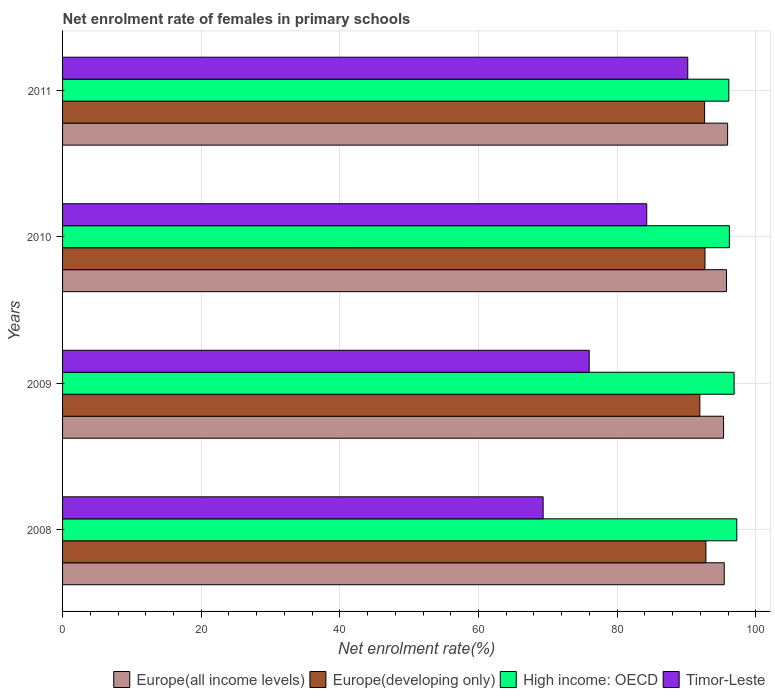How many different coloured bars are there?
Make the answer very short. 4. How many groups of bars are there?
Offer a very short reply. 4. Are the number of bars on each tick of the Y-axis equal?
Ensure brevity in your answer.  Yes. How many bars are there on the 3rd tick from the top?
Offer a very short reply. 4. What is the label of the 2nd group of bars from the top?
Make the answer very short. 2010. What is the net enrolment rate of females in primary schools in Europe(all income levels) in 2009?
Provide a succinct answer. 95.35. Across all years, what is the maximum net enrolment rate of females in primary schools in Europe(developing only)?
Provide a short and direct response. 92.81. Across all years, what is the minimum net enrolment rate of females in primary schools in Timor-Leste?
Provide a short and direct response. 69.33. In which year was the net enrolment rate of females in primary schools in Timor-Leste minimum?
Offer a terse response. 2008. What is the total net enrolment rate of females in primary schools in Europe(developing only) in the graph?
Offer a very short reply. 370.04. What is the difference between the net enrolment rate of females in primary schools in Timor-Leste in 2009 and that in 2011?
Offer a terse response. -14.22. What is the difference between the net enrolment rate of females in primary schools in Europe(developing only) in 2009 and the net enrolment rate of females in primary schools in Timor-Leste in 2011?
Your answer should be very brief. 1.74. What is the average net enrolment rate of females in primary schools in Timor-Leste per year?
Provide a succinct answer. 79.94. In the year 2011, what is the difference between the net enrolment rate of females in primary schools in Europe(all income levels) and net enrolment rate of females in primary schools in Europe(developing only)?
Provide a succinct answer. 3.32. In how many years, is the net enrolment rate of females in primary schools in Timor-Leste greater than 40 %?
Give a very brief answer. 4. What is the ratio of the net enrolment rate of females in primary schools in Timor-Leste in 2010 to that in 2011?
Keep it short and to the point. 0.93. What is the difference between the highest and the second highest net enrolment rate of females in primary schools in Timor-Leste?
Ensure brevity in your answer.  5.92. What is the difference between the highest and the lowest net enrolment rate of females in primary schools in Europe(all income levels)?
Provide a short and direct response. 0.59. In how many years, is the net enrolment rate of females in primary schools in High income: OECD greater than the average net enrolment rate of females in primary schools in High income: OECD taken over all years?
Offer a terse response. 2. Is it the case that in every year, the sum of the net enrolment rate of females in primary schools in Europe(all income levels) and net enrolment rate of females in primary schools in Timor-Leste is greater than the sum of net enrolment rate of females in primary schools in Europe(developing only) and net enrolment rate of females in primary schools in High income: OECD?
Ensure brevity in your answer.  No. What does the 3rd bar from the top in 2010 represents?
Offer a very short reply. Europe(developing only). What does the 4th bar from the bottom in 2008 represents?
Provide a succinct answer. Timor-Leste. How many bars are there?
Ensure brevity in your answer.  16. Are all the bars in the graph horizontal?
Ensure brevity in your answer.  Yes. What is the difference between two consecutive major ticks on the X-axis?
Keep it short and to the point. 20. Are the values on the major ticks of X-axis written in scientific E-notation?
Make the answer very short. No. Does the graph contain any zero values?
Ensure brevity in your answer.  No. Does the graph contain grids?
Give a very brief answer. Yes. Where does the legend appear in the graph?
Give a very brief answer. Bottom right. What is the title of the graph?
Your answer should be very brief. Net enrolment rate of females in primary schools. What is the label or title of the X-axis?
Make the answer very short. Net enrolment rate(%). What is the label or title of the Y-axis?
Keep it short and to the point. Years. What is the Net enrolment rate(%) in Europe(all income levels) in 2008?
Your answer should be very brief. 95.45. What is the Net enrolment rate(%) in Europe(developing only) in 2008?
Ensure brevity in your answer.  92.81. What is the Net enrolment rate(%) of High income: OECD in 2008?
Keep it short and to the point. 97.26. What is the Net enrolment rate(%) in Timor-Leste in 2008?
Your response must be concise. 69.33. What is the Net enrolment rate(%) of Europe(all income levels) in 2009?
Make the answer very short. 95.35. What is the Net enrolment rate(%) in Europe(developing only) in 2009?
Your answer should be very brief. 91.93. What is the Net enrolment rate(%) of High income: OECD in 2009?
Offer a terse response. 96.87. What is the Net enrolment rate(%) in Timor-Leste in 2009?
Keep it short and to the point. 75.97. What is the Net enrolment rate(%) in Europe(all income levels) in 2010?
Your response must be concise. 95.78. What is the Net enrolment rate(%) of Europe(developing only) in 2010?
Offer a terse response. 92.67. What is the Net enrolment rate(%) in High income: OECD in 2010?
Provide a succinct answer. 96.19. What is the Net enrolment rate(%) of Timor-Leste in 2010?
Offer a terse response. 84.27. What is the Net enrolment rate(%) in Europe(all income levels) in 2011?
Make the answer very short. 95.94. What is the Net enrolment rate(%) of Europe(developing only) in 2011?
Provide a succinct answer. 92.62. What is the Net enrolment rate(%) of High income: OECD in 2011?
Offer a very short reply. 96.12. What is the Net enrolment rate(%) of Timor-Leste in 2011?
Give a very brief answer. 90.19. Across all years, what is the maximum Net enrolment rate(%) in Europe(all income levels)?
Offer a terse response. 95.94. Across all years, what is the maximum Net enrolment rate(%) in Europe(developing only)?
Your response must be concise. 92.81. Across all years, what is the maximum Net enrolment rate(%) of High income: OECD?
Offer a very short reply. 97.26. Across all years, what is the maximum Net enrolment rate(%) in Timor-Leste?
Your answer should be compact. 90.19. Across all years, what is the minimum Net enrolment rate(%) in Europe(all income levels)?
Ensure brevity in your answer.  95.35. Across all years, what is the minimum Net enrolment rate(%) of Europe(developing only)?
Provide a succinct answer. 91.93. Across all years, what is the minimum Net enrolment rate(%) of High income: OECD?
Ensure brevity in your answer.  96.12. Across all years, what is the minimum Net enrolment rate(%) of Timor-Leste?
Your answer should be compact. 69.33. What is the total Net enrolment rate(%) of Europe(all income levels) in the graph?
Make the answer very short. 382.52. What is the total Net enrolment rate(%) in Europe(developing only) in the graph?
Your answer should be very brief. 370.04. What is the total Net enrolment rate(%) of High income: OECD in the graph?
Provide a short and direct response. 386.44. What is the total Net enrolment rate(%) of Timor-Leste in the graph?
Your answer should be very brief. 319.76. What is the difference between the Net enrolment rate(%) of Europe(all income levels) in 2008 and that in 2009?
Provide a succinct answer. 0.1. What is the difference between the Net enrolment rate(%) of Europe(developing only) in 2008 and that in 2009?
Offer a terse response. 0.88. What is the difference between the Net enrolment rate(%) in High income: OECD in 2008 and that in 2009?
Provide a short and direct response. 0.39. What is the difference between the Net enrolment rate(%) of Timor-Leste in 2008 and that in 2009?
Your response must be concise. -6.64. What is the difference between the Net enrolment rate(%) in Europe(all income levels) in 2008 and that in 2010?
Give a very brief answer. -0.32. What is the difference between the Net enrolment rate(%) of Europe(developing only) in 2008 and that in 2010?
Keep it short and to the point. 0.13. What is the difference between the Net enrolment rate(%) of High income: OECD in 2008 and that in 2010?
Offer a very short reply. 1.07. What is the difference between the Net enrolment rate(%) in Timor-Leste in 2008 and that in 2010?
Provide a short and direct response. -14.94. What is the difference between the Net enrolment rate(%) in Europe(all income levels) in 2008 and that in 2011?
Offer a very short reply. -0.49. What is the difference between the Net enrolment rate(%) of Europe(developing only) in 2008 and that in 2011?
Your response must be concise. 0.19. What is the difference between the Net enrolment rate(%) of High income: OECD in 2008 and that in 2011?
Offer a terse response. 1.15. What is the difference between the Net enrolment rate(%) of Timor-Leste in 2008 and that in 2011?
Your answer should be compact. -20.86. What is the difference between the Net enrolment rate(%) in Europe(all income levels) in 2009 and that in 2010?
Keep it short and to the point. -0.42. What is the difference between the Net enrolment rate(%) in Europe(developing only) in 2009 and that in 2010?
Give a very brief answer. -0.74. What is the difference between the Net enrolment rate(%) in High income: OECD in 2009 and that in 2010?
Ensure brevity in your answer.  0.68. What is the difference between the Net enrolment rate(%) in Timor-Leste in 2009 and that in 2010?
Provide a succinct answer. -8.3. What is the difference between the Net enrolment rate(%) of Europe(all income levels) in 2009 and that in 2011?
Make the answer very short. -0.59. What is the difference between the Net enrolment rate(%) of Europe(developing only) in 2009 and that in 2011?
Your answer should be very brief. -0.69. What is the difference between the Net enrolment rate(%) of High income: OECD in 2009 and that in 2011?
Provide a short and direct response. 0.76. What is the difference between the Net enrolment rate(%) of Timor-Leste in 2009 and that in 2011?
Offer a terse response. -14.22. What is the difference between the Net enrolment rate(%) in Europe(all income levels) in 2010 and that in 2011?
Give a very brief answer. -0.16. What is the difference between the Net enrolment rate(%) in Europe(developing only) in 2010 and that in 2011?
Your answer should be very brief. 0.05. What is the difference between the Net enrolment rate(%) in High income: OECD in 2010 and that in 2011?
Keep it short and to the point. 0.08. What is the difference between the Net enrolment rate(%) in Timor-Leste in 2010 and that in 2011?
Your response must be concise. -5.92. What is the difference between the Net enrolment rate(%) in Europe(all income levels) in 2008 and the Net enrolment rate(%) in Europe(developing only) in 2009?
Offer a very short reply. 3.52. What is the difference between the Net enrolment rate(%) in Europe(all income levels) in 2008 and the Net enrolment rate(%) in High income: OECD in 2009?
Offer a very short reply. -1.42. What is the difference between the Net enrolment rate(%) of Europe(all income levels) in 2008 and the Net enrolment rate(%) of Timor-Leste in 2009?
Offer a very short reply. 19.48. What is the difference between the Net enrolment rate(%) in Europe(developing only) in 2008 and the Net enrolment rate(%) in High income: OECD in 2009?
Offer a very short reply. -4.06. What is the difference between the Net enrolment rate(%) of Europe(developing only) in 2008 and the Net enrolment rate(%) of Timor-Leste in 2009?
Make the answer very short. 16.84. What is the difference between the Net enrolment rate(%) of High income: OECD in 2008 and the Net enrolment rate(%) of Timor-Leste in 2009?
Your answer should be compact. 21.29. What is the difference between the Net enrolment rate(%) of Europe(all income levels) in 2008 and the Net enrolment rate(%) of Europe(developing only) in 2010?
Ensure brevity in your answer.  2.78. What is the difference between the Net enrolment rate(%) of Europe(all income levels) in 2008 and the Net enrolment rate(%) of High income: OECD in 2010?
Make the answer very short. -0.74. What is the difference between the Net enrolment rate(%) of Europe(all income levels) in 2008 and the Net enrolment rate(%) of Timor-Leste in 2010?
Ensure brevity in your answer.  11.19. What is the difference between the Net enrolment rate(%) in Europe(developing only) in 2008 and the Net enrolment rate(%) in High income: OECD in 2010?
Your answer should be compact. -3.39. What is the difference between the Net enrolment rate(%) in Europe(developing only) in 2008 and the Net enrolment rate(%) in Timor-Leste in 2010?
Make the answer very short. 8.54. What is the difference between the Net enrolment rate(%) of High income: OECD in 2008 and the Net enrolment rate(%) of Timor-Leste in 2010?
Your answer should be compact. 12.99. What is the difference between the Net enrolment rate(%) in Europe(all income levels) in 2008 and the Net enrolment rate(%) in Europe(developing only) in 2011?
Provide a succinct answer. 2.83. What is the difference between the Net enrolment rate(%) of Europe(all income levels) in 2008 and the Net enrolment rate(%) of High income: OECD in 2011?
Your answer should be compact. -0.66. What is the difference between the Net enrolment rate(%) of Europe(all income levels) in 2008 and the Net enrolment rate(%) of Timor-Leste in 2011?
Your response must be concise. 5.26. What is the difference between the Net enrolment rate(%) of Europe(developing only) in 2008 and the Net enrolment rate(%) of High income: OECD in 2011?
Give a very brief answer. -3.31. What is the difference between the Net enrolment rate(%) of Europe(developing only) in 2008 and the Net enrolment rate(%) of Timor-Leste in 2011?
Keep it short and to the point. 2.62. What is the difference between the Net enrolment rate(%) of High income: OECD in 2008 and the Net enrolment rate(%) of Timor-Leste in 2011?
Provide a short and direct response. 7.07. What is the difference between the Net enrolment rate(%) in Europe(all income levels) in 2009 and the Net enrolment rate(%) in Europe(developing only) in 2010?
Your answer should be very brief. 2.68. What is the difference between the Net enrolment rate(%) in Europe(all income levels) in 2009 and the Net enrolment rate(%) in High income: OECD in 2010?
Give a very brief answer. -0.84. What is the difference between the Net enrolment rate(%) in Europe(all income levels) in 2009 and the Net enrolment rate(%) in Timor-Leste in 2010?
Your answer should be compact. 11.09. What is the difference between the Net enrolment rate(%) of Europe(developing only) in 2009 and the Net enrolment rate(%) of High income: OECD in 2010?
Provide a short and direct response. -4.26. What is the difference between the Net enrolment rate(%) of Europe(developing only) in 2009 and the Net enrolment rate(%) of Timor-Leste in 2010?
Ensure brevity in your answer.  7.66. What is the difference between the Net enrolment rate(%) of High income: OECD in 2009 and the Net enrolment rate(%) of Timor-Leste in 2010?
Make the answer very short. 12.6. What is the difference between the Net enrolment rate(%) of Europe(all income levels) in 2009 and the Net enrolment rate(%) of Europe(developing only) in 2011?
Offer a very short reply. 2.73. What is the difference between the Net enrolment rate(%) of Europe(all income levels) in 2009 and the Net enrolment rate(%) of High income: OECD in 2011?
Provide a succinct answer. -0.76. What is the difference between the Net enrolment rate(%) of Europe(all income levels) in 2009 and the Net enrolment rate(%) of Timor-Leste in 2011?
Provide a short and direct response. 5.16. What is the difference between the Net enrolment rate(%) in Europe(developing only) in 2009 and the Net enrolment rate(%) in High income: OECD in 2011?
Your answer should be very brief. -4.18. What is the difference between the Net enrolment rate(%) of Europe(developing only) in 2009 and the Net enrolment rate(%) of Timor-Leste in 2011?
Offer a terse response. 1.74. What is the difference between the Net enrolment rate(%) in High income: OECD in 2009 and the Net enrolment rate(%) in Timor-Leste in 2011?
Keep it short and to the point. 6.68. What is the difference between the Net enrolment rate(%) in Europe(all income levels) in 2010 and the Net enrolment rate(%) in Europe(developing only) in 2011?
Give a very brief answer. 3.15. What is the difference between the Net enrolment rate(%) of Europe(all income levels) in 2010 and the Net enrolment rate(%) of High income: OECD in 2011?
Your response must be concise. -0.34. What is the difference between the Net enrolment rate(%) of Europe(all income levels) in 2010 and the Net enrolment rate(%) of Timor-Leste in 2011?
Your answer should be very brief. 5.59. What is the difference between the Net enrolment rate(%) of Europe(developing only) in 2010 and the Net enrolment rate(%) of High income: OECD in 2011?
Ensure brevity in your answer.  -3.44. What is the difference between the Net enrolment rate(%) in Europe(developing only) in 2010 and the Net enrolment rate(%) in Timor-Leste in 2011?
Keep it short and to the point. 2.48. What is the difference between the Net enrolment rate(%) in High income: OECD in 2010 and the Net enrolment rate(%) in Timor-Leste in 2011?
Ensure brevity in your answer.  6.01. What is the average Net enrolment rate(%) in Europe(all income levels) per year?
Provide a short and direct response. 95.63. What is the average Net enrolment rate(%) in Europe(developing only) per year?
Your response must be concise. 92.51. What is the average Net enrolment rate(%) in High income: OECD per year?
Offer a very short reply. 96.61. What is the average Net enrolment rate(%) in Timor-Leste per year?
Your answer should be very brief. 79.94. In the year 2008, what is the difference between the Net enrolment rate(%) of Europe(all income levels) and Net enrolment rate(%) of Europe(developing only)?
Give a very brief answer. 2.65. In the year 2008, what is the difference between the Net enrolment rate(%) in Europe(all income levels) and Net enrolment rate(%) in High income: OECD?
Provide a short and direct response. -1.81. In the year 2008, what is the difference between the Net enrolment rate(%) of Europe(all income levels) and Net enrolment rate(%) of Timor-Leste?
Give a very brief answer. 26.13. In the year 2008, what is the difference between the Net enrolment rate(%) in Europe(developing only) and Net enrolment rate(%) in High income: OECD?
Ensure brevity in your answer.  -4.45. In the year 2008, what is the difference between the Net enrolment rate(%) of Europe(developing only) and Net enrolment rate(%) of Timor-Leste?
Your answer should be very brief. 23.48. In the year 2008, what is the difference between the Net enrolment rate(%) in High income: OECD and Net enrolment rate(%) in Timor-Leste?
Your response must be concise. 27.93. In the year 2009, what is the difference between the Net enrolment rate(%) of Europe(all income levels) and Net enrolment rate(%) of Europe(developing only)?
Provide a succinct answer. 3.42. In the year 2009, what is the difference between the Net enrolment rate(%) in Europe(all income levels) and Net enrolment rate(%) in High income: OECD?
Your answer should be compact. -1.52. In the year 2009, what is the difference between the Net enrolment rate(%) of Europe(all income levels) and Net enrolment rate(%) of Timor-Leste?
Provide a succinct answer. 19.38. In the year 2009, what is the difference between the Net enrolment rate(%) in Europe(developing only) and Net enrolment rate(%) in High income: OECD?
Give a very brief answer. -4.94. In the year 2009, what is the difference between the Net enrolment rate(%) in Europe(developing only) and Net enrolment rate(%) in Timor-Leste?
Your answer should be compact. 15.96. In the year 2009, what is the difference between the Net enrolment rate(%) in High income: OECD and Net enrolment rate(%) in Timor-Leste?
Ensure brevity in your answer.  20.9. In the year 2010, what is the difference between the Net enrolment rate(%) in Europe(all income levels) and Net enrolment rate(%) in Europe(developing only)?
Your answer should be compact. 3.1. In the year 2010, what is the difference between the Net enrolment rate(%) in Europe(all income levels) and Net enrolment rate(%) in High income: OECD?
Your response must be concise. -0.42. In the year 2010, what is the difference between the Net enrolment rate(%) in Europe(all income levels) and Net enrolment rate(%) in Timor-Leste?
Keep it short and to the point. 11.51. In the year 2010, what is the difference between the Net enrolment rate(%) of Europe(developing only) and Net enrolment rate(%) of High income: OECD?
Keep it short and to the point. -3.52. In the year 2010, what is the difference between the Net enrolment rate(%) in Europe(developing only) and Net enrolment rate(%) in Timor-Leste?
Your answer should be very brief. 8.41. In the year 2010, what is the difference between the Net enrolment rate(%) in High income: OECD and Net enrolment rate(%) in Timor-Leste?
Your answer should be very brief. 11.93. In the year 2011, what is the difference between the Net enrolment rate(%) of Europe(all income levels) and Net enrolment rate(%) of Europe(developing only)?
Ensure brevity in your answer.  3.32. In the year 2011, what is the difference between the Net enrolment rate(%) in Europe(all income levels) and Net enrolment rate(%) in High income: OECD?
Provide a short and direct response. -0.18. In the year 2011, what is the difference between the Net enrolment rate(%) of Europe(all income levels) and Net enrolment rate(%) of Timor-Leste?
Give a very brief answer. 5.75. In the year 2011, what is the difference between the Net enrolment rate(%) of Europe(developing only) and Net enrolment rate(%) of High income: OECD?
Provide a succinct answer. -3.49. In the year 2011, what is the difference between the Net enrolment rate(%) in Europe(developing only) and Net enrolment rate(%) in Timor-Leste?
Provide a short and direct response. 2.43. In the year 2011, what is the difference between the Net enrolment rate(%) in High income: OECD and Net enrolment rate(%) in Timor-Leste?
Offer a terse response. 5.93. What is the ratio of the Net enrolment rate(%) in Europe(all income levels) in 2008 to that in 2009?
Your response must be concise. 1. What is the ratio of the Net enrolment rate(%) of Europe(developing only) in 2008 to that in 2009?
Offer a very short reply. 1.01. What is the ratio of the Net enrolment rate(%) in Timor-Leste in 2008 to that in 2009?
Give a very brief answer. 0.91. What is the ratio of the Net enrolment rate(%) in Europe(all income levels) in 2008 to that in 2010?
Ensure brevity in your answer.  1. What is the ratio of the Net enrolment rate(%) in Europe(developing only) in 2008 to that in 2010?
Provide a short and direct response. 1. What is the ratio of the Net enrolment rate(%) of High income: OECD in 2008 to that in 2010?
Your answer should be compact. 1.01. What is the ratio of the Net enrolment rate(%) in Timor-Leste in 2008 to that in 2010?
Provide a succinct answer. 0.82. What is the ratio of the Net enrolment rate(%) of Europe(all income levels) in 2008 to that in 2011?
Provide a succinct answer. 0.99. What is the ratio of the Net enrolment rate(%) of High income: OECD in 2008 to that in 2011?
Provide a short and direct response. 1.01. What is the ratio of the Net enrolment rate(%) of Timor-Leste in 2008 to that in 2011?
Ensure brevity in your answer.  0.77. What is the ratio of the Net enrolment rate(%) of Europe(all income levels) in 2009 to that in 2010?
Give a very brief answer. 1. What is the ratio of the Net enrolment rate(%) of High income: OECD in 2009 to that in 2010?
Give a very brief answer. 1.01. What is the ratio of the Net enrolment rate(%) of Timor-Leste in 2009 to that in 2010?
Your answer should be very brief. 0.9. What is the ratio of the Net enrolment rate(%) in Europe(all income levels) in 2009 to that in 2011?
Offer a very short reply. 0.99. What is the ratio of the Net enrolment rate(%) of Europe(developing only) in 2009 to that in 2011?
Keep it short and to the point. 0.99. What is the ratio of the Net enrolment rate(%) in High income: OECD in 2009 to that in 2011?
Ensure brevity in your answer.  1.01. What is the ratio of the Net enrolment rate(%) of Timor-Leste in 2009 to that in 2011?
Your answer should be very brief. 0.84. What is the ratio of the Net enrolment rate(%) of Europe(all income levels) in 2010 to that in 2011?
Your answer should be very brief. 1. What is the ratio of the Net enrolment rate(%) in Europe(developing only) in 2010 to that in 2011?
Give a very brief answer. 1. What is the ratio of the Net enrolment rate(%) of High income: OECD in 2010 to that in 2011?
Make the answer very short. 1. What is the ratio of the Net enrolment rate(%) of Timor-Leste in 2010 to that in 2011?
Your answer should be very brief. 0.93. What is the difference between the highest and the second highest Net enrolment rate(%) in Europe(all income levels)?
Offer a very short reply. 0.16. What is the difference between the highest and the second highest Net enrolment rate(%) in Europe(developing only)?
Offer a terse response. 0.13. What is the difference between the highest and the second highest Net enrolment rate(%) in High income: OECD?
Ensure brevity in your answer.  0.39. What is the difference between the highest and the second highest Net enrolment rate(%) of Timor-Leste?
Make the answer very short. 5.92. What is the difference between the highest and the lowest Net enrolment rate(%) of Europe(all income levels)?
Offer a terse response. 0.59. What is the difference between the highest and the lowest Net enrolment rate(%) in Europe(developing only)?
Ensure brevity in your answer.  0.88. What is the difference between the highest and the lowest Net enrolment rate(%) of High income: OECD?
Provide a succinct answer. 1.15. What is the difference between the highest and the lowest Net enrolment rate(%) in Timor-Leste?
Keep it short and to the point. 20.86. 